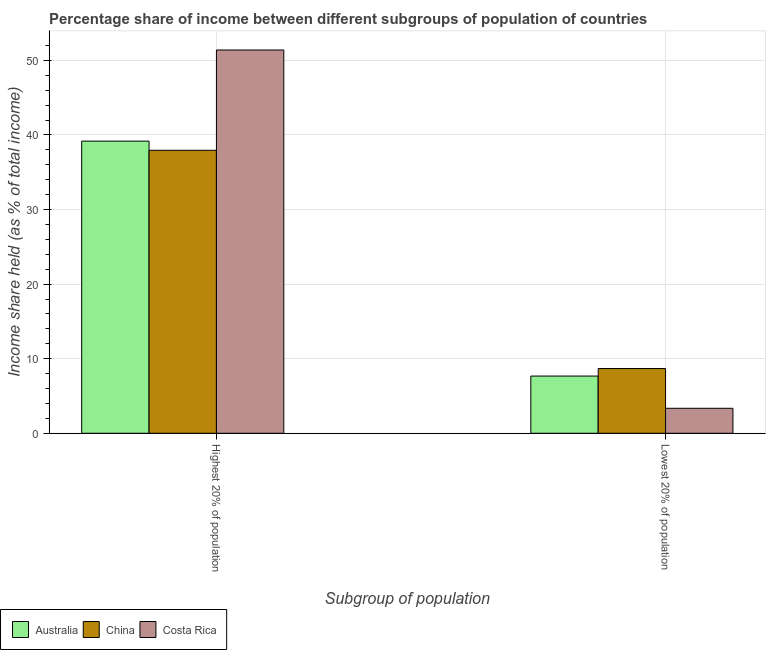Are the number of bars per tick equal to the number of legend labels?
Your response must be concise. Yes. Are the number of bars on each tick of the X-axis equal?
Your response must be concise. Yes. What is the label of the 2nd group of bars from the left?
Ensure brevity in your answer.  Lowest 20% of population. What is the income share held by lowest 20% of the population in Costa Rica?
Keep it short and to the point. 3.35. Across all countries, what is the maximum income share held by lowest 20% of the population?
Offer a terse response. 8.68. Across all countries, what is the minimum income share held by highest 20% of the population?
Your answer should be compact. 37.94. What is the total income share held by highest 20% of the population in the graph?
Provide a succinct answer. 128.5. What is the difference between the income share held by highest 20% of the population in Australia and that in China?
Offer a terse response. 1.23. What is the difference between the income share held by lowest 20% of the population in Costa Rica and the income share held by highest 20% of the population in China?
Ensure brevity in your answer.  -34.59. What is the average income share held by highest 20% of the population per country?
Give a very brief answer. 42.83. What is the difference between the income share held by lowest 20% of the population and income share held by highest 20% of the population in China?
Your response must be concise. -29.26. In how many countries, is the income share held by lowest 20% of the population greater than 2 %?
Your answer should be compact. 3. What is the ratio of the income share held by lowest 20% of the population in Costa Rica to that in China?
Offer a terse response. 0.39. Is the income share held by highest 20% of the population in Costa Rica less than that in Australia?
Provide a succinct answer. No. In how many countries, is the income share held by highest 20% of the population greater than the average income share held by highest 20% of the population taken over all countries?
Offer a very short reply. 1. Does the graph contain any zero values?
Ensure brevity in your answer.  No. Does the graph contain grids?
Give a very brief answer. Yes. What is the title of the graph?
Ensure brevity in your answer.  Percentage share of income between different subgroups of population of countries. Does "Barbados" appear as one of the legend labels in the graph?
Ensure brevity in your answer.  No. What is the label or title of the X-axis?
Provide a succinct answer. Subgroup of population. What is the label or title of the Y-axis?
Ensure brevity in your answer.  Income share held (as % of total income). What is the Income share held (as % of total income) of Australia in Highest 20% of population?
Make the answer very short. 39.17. What is the Income share held (as % of total income) of China in Highest 20% of population?
Ensure brevity in your answer.  37.94. What is the Income share held (as % of total income) in Costa Rica in Highest 20% of population?
Give a very brief answer. 51.39. What is the Income share held (as % of total income) of Australia in Lowest 20% of population?
Keep it short and to the point. 7.67. What is the Income share held (as % of total income) of China in Lowest 20% of population?
Your response must be concise. 8.68. What is the Income share held (as % of total income) in Costa Rica in Lowest 20% of population?
Ensure brevity in your answer.  3.35. Across all Subgroup of population, what is the maximum Income share held (as % of total income) in Australia?
Offer a terse response. 39.17. Across all Subgroup of population, what is the maximum Income share held (as % of total income) of China?
Your answer should be very brief. 37.94. Across all Subgroup of population, what is the maximum Income share held (as % of total income) in Costa Rica?
Give a very brief answer. 51.39. Across all Subgroup of population, what is the minimum Income share held (as % of total income) in Australia?
Your answer should be very brief. 7.67. Across all Subgroup of population, what is the minimum Income share held (as % of total income) of China?
Make the answer very short. 8.68. Across all Subgroup of population, what is the minimum Income share held (as % of total income) in Costa Rica?
Keep it short and to the point. 3.35. What is the total Income share held (as % of total income) of Australia in the graph?
Offer a terse response. 46.84. What is the total Income share held (as % of total income) in China in the graph?
Offer a terse response. 46.62. What is the total Income share held (as % of total income) of Costa Rica in the graph?
Offer a very short reply. 54.74. What is the difference between the Income share held (as % of total income) of Australia in Highest 20% of population and that in Lowest 20% of population?
Provide a short and direct response. 31.5. What is the difference between the Income share held (as % of total income) in China in Highest 20% of population and that in Lowest 20% of population?
Offer a very short reply. 29.26. What is the difference between the Income share held (as % of total income) in Costa Rica in Highest 20% of population and that in Lowest 20% of population?
Provide a succinct answer. 48.04. What is the difference between the Income share held (as % of total income) in Australia in Highest 20% of population and the Income share held (as % of total income) in China in Lowest 20% of population?
Your answer should be compact. 30.49. What is the difference between the Income share held (as % of total income) of Australia in Highest 20% of population and the Income share held (as % of total income) of Costa Rica in Lowest 20% of population?
Offer a terse response. 35.82. What is the difference between the Income share held (as % of total income) of China in Highest 20% of population and the Income share held (as % of total income) of Costa Rica in Lowest 20% of population?
Your response must be concise. 34.59. What is the average Income share held (as % of total income) in Australia per Subgroup of population?
Provide a short and direct response. 23.42. What is the average Income share held (as % of total income) of China per Subgroup of population?
Your response must be concise. 23.31. What is the average Income share held (as % of total income) of Costa Rica per Subgroup of population?
Your answer should be very brief. 27.37. What is the difference between the Income share held (as % of total income) in Australia and Income share held (as % of total income) in China in Highest 20% of population?
Your answer should be very brief. 1.23. What is the difference between the Income share held (as % of total income) in Australia and Income share held (as % of total income) in Costa Rica in Highest 20% of population?
Make the answer very short. -12.22. What is the difference between the Income share held (as % of total income) of China and Income share held (as % of total income) of Costa Rica in Highest 20% of population?
Your response must be concise. -13.45. What is the difference between the Income share held (as % of total income) of Australia and Income share held (as % of total income) of China in Lowest 20% of population?
Provide a succinct answer. -1.01. What is the difference between the Income share held (as % of total income) in Australia and Income share held (as % of total income) in Costa Rica in Lowest 20% of population?
Keep it short and to the point. 4.32. What is the difference between the Income share held (as % of total income) in China and Income share held (as % of total income) in Costa Rica in Lowest 20% of population?
Offer a terse response. 5.33. What is the ratio of the Income share held (as % of total income) of Australia in Highest 20% of population to that in Lowest 20% of population?
Provide a short and direct response. 5.11. What is the ratio of the Income share held (as % of total income) in China in Highest 20% of population to that in Lowest 20% of population?
Offer a very short reply. 4.37. What is the ratio of the Income share held (as % of total income) of Costa Rica in Highest 20% of population to that in Lowest 20% of population?
Offer a terse response. 15.34. What is the difference between the highest and the second highest Income share held (as % of total income) in Australia?
Your answer should be compact. 31.5. What is the difference between the highest and the second highest Income share held (as % of total income) of China?
Make the answer very short. 29.26. What is the difference between the highest and the second highest Income share held (as % of total income) of Costa Rica?
Provide a succinct answer. 48.04. What is the difference between the highest and the lowest Income share held (as % of total income) of Australia?
Your response must be concise. 31.5. What is the difference between the highest and the lowest Income share held (as % of total income) in China?
Provide a succinct answer. 29.26. What is the difference between the highest and the lowest Income share held (as % of total income) in Costa Rica?
Offer a terse response. 48.04. 